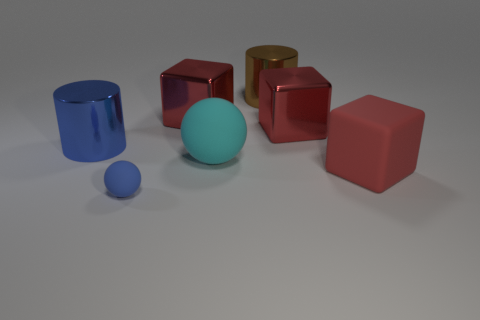Subtract all large metal blocks. How many blocks are left? 1 Add 1 big matte balls. How many objects exist? 8 Subtract all blocks. How many objects are left? 4 Subtract 1 cylinders. How many cylinders are left? 1 Subtract all green spheres. How many purple blocks are left? 0 Subtract 0 purple spheres. How many objects are left? 7 Subtract all yellow spheres. Subtract all blue cylinders. How many spheres are left? 2 Subtract all big cyan rubber balls. Subtract all large cyan objects. How many objects are left? 5 Add 6 big red metal blocks. How many big red metal blocks are left? 8 Add 3 tiny rubber balls. How many tiny rubber balls exist? 4 